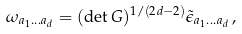Convert formula to latex. <formula><loc_0><loc_0><loc_500><loc_500>\omega _ { a _ { 1 } \dots a _ { d } } = ( \det G ) ^ { 1 / ( 2 d - 2 ) } \tilde { \epsilon } _ { a _ { 1 } \dots a _ { d } } \, ,</formula> 